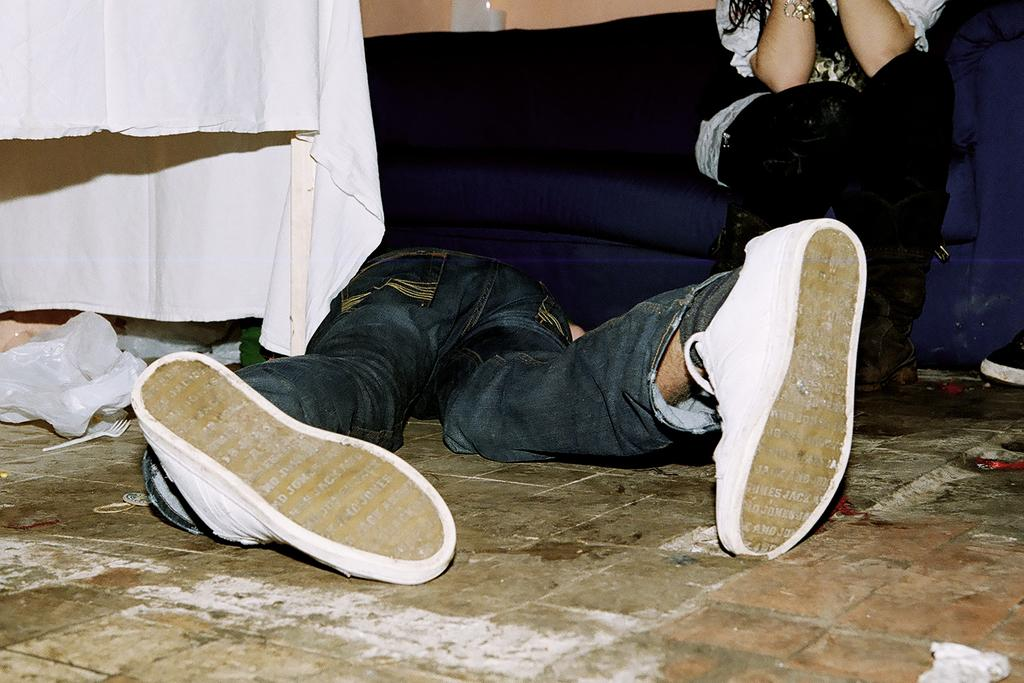What is located on the left side of the image? There is a table on the left side of the image. What is covering the table? There is a cloth or cover on the table. What utensil can be seen on the table? There is a fork on the table. What is the main subject in the center of the image? There is a person lying in the center of the image. What is the woman doing on the right side of the image? The woman is sitting on the couch on the right side of the image. Can you tell me how many giraffes are standing on the couch in the image? There are no giraffes present in the image; the woman is sitting on the couch. What shape is the food on the table in the image? There is no food present in the image, so we cannot determine its shape. 